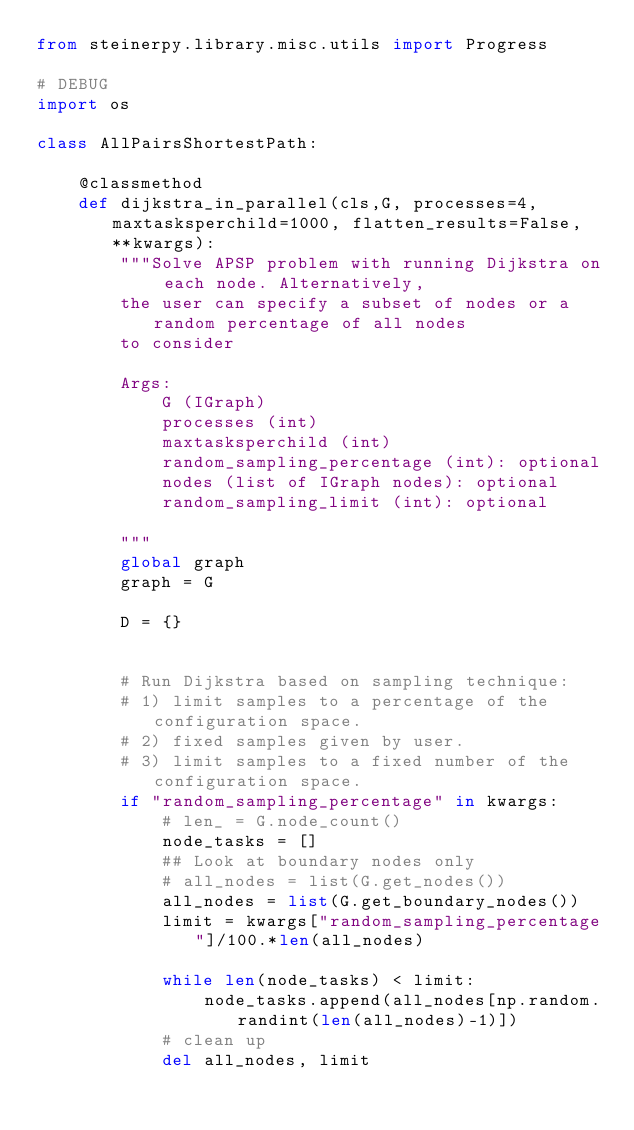<code> <loc_0><loc_0><loc_500><loc_500><_Python_>from steinerpy.library.misc.utils import Progress

# DEBUG
import os

class AllPairsShortestPath:

    @classmethod
    def dijkstra_in_parallel(cls,G, processes=4, maxtasksperchild=1000, flatten_results=False, **kwargs):
        """Solve APSP problem with running Dijkstra on each node. Alternatively,
        the user can specify a subset of nodes or a random percentage of all nodes
        to consider

        Args:
            G (IGraph)
            processes (int)
            maxtasksperchild (int)
            random_sampling_percentage (int): optional
            nodes (list of IGraph nodes): optional
            random_sampling_limit (int): optional

        """
        global graph
        graph = G

        D = {}


        # Run Dijkstra based on sampling technique:
        # 1) limit samples to a percentage of the configuration space.
        # 2) fixed samples given by user.
        # 3) limit samples to a fixed number of the configuration space.
        if "random_sampling_percentage" in kwargs:
            # len_ = G.node_count()
            node_tasks = []
            ## Look at boundary nodes only
            # all_nodes = list(G.get_nodes())
            all_nodes = list(G.get_boundary_nodes())
            limit = kwargs["random_sampling_percentage"]/100.*len(all_nodes)

            while len(node_tasks) < limit:
                node_tasks.append(all_nodes[np.random.randint(len(all_nodes)-1)])
            # clean up
            del all_nodes, limit</code> 